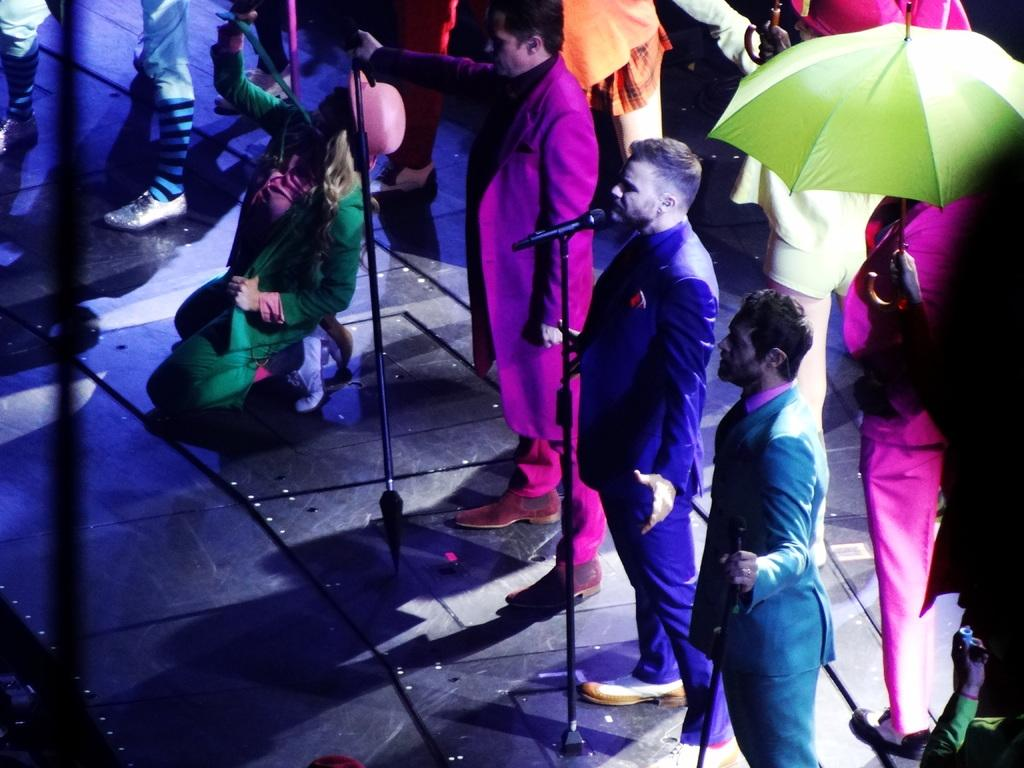How many people are in the image? There is a group of people in the image. What are the people doing in the image? The people are standing in front of a microphone. What color is the umbrella in the image? There is a green-colored umbrella in the image. What can be seen in the background of the image? The background of the image includes multi-colored lights. What type of watch is the person wearing in the image? There is no watch visible in the image. What holiday is being celebrated in the image? There is no indication of a holiday being celebrated in the image. 